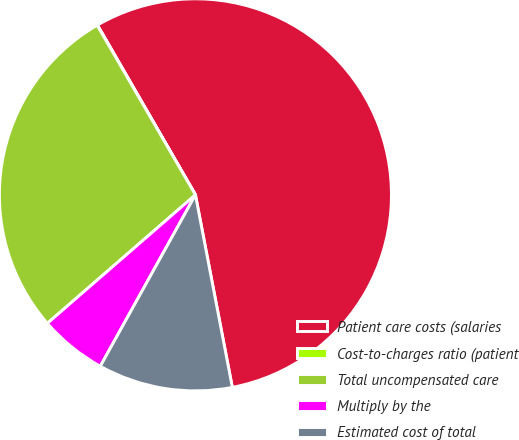Convert chart to OTSL. <chart><loc_0><loc_0><loc_500><loc_500><pie_chart><fcel>Patient care costs (salaries<fcel>Cost-to-charges ratio (patient<fcel>Total uncompensated care<fcel>Multiply by the<fcel>Estimated cost of total<nl><fcel>55.32%<fcel>0.03%<fcel>28.02%<fcel>5.56%<fcel>11.08%<nl></chart> 